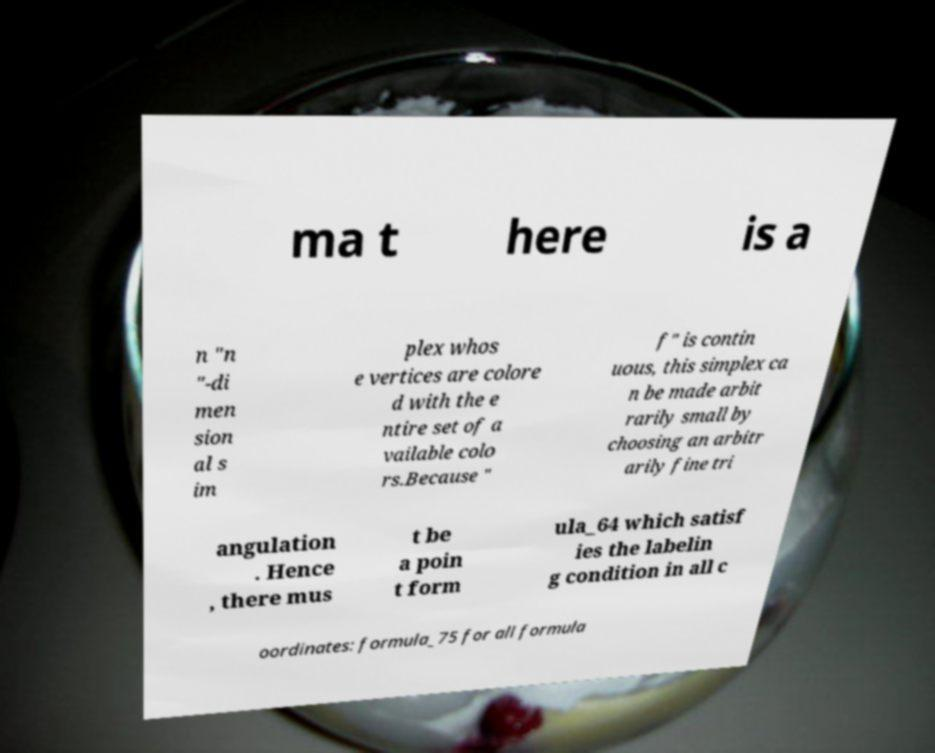Can you read and provide the text displayed in the image?This photo seems to have some interesting text. Can you extract and type it out for me? ma t here is a n "n "-di men sion al s im plex whos e vertices are colore d with the e ntire set of a vailable colo rs.Because " f" is contin uous, this simplex ca n be made arbit rarily small by choosing an arbitr arily fine tri angulation . Hence , there mus t be a poin t form ula_64 which satisf ies the labelin g condition in all c oordinates: formula_75 for all formula 